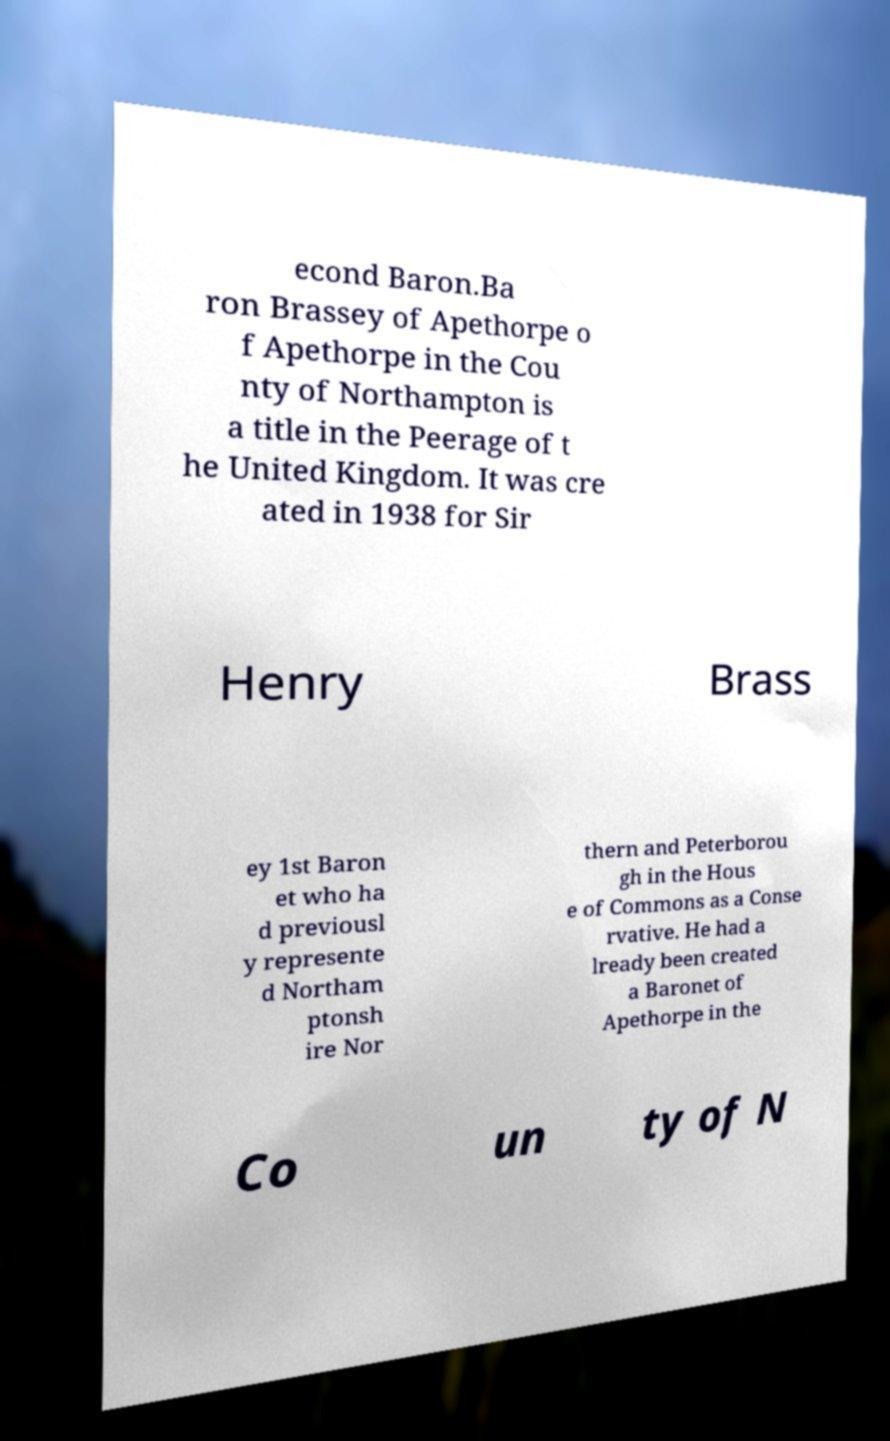Please read and relay the text visible in this image. What does it say? econd Baron.Ba ron Brassey of Apethorpe o f Apethorpe in the Cou nty of Northampton is a title in the Peerage of t he United Kingdom. It was cre ated in 1938 for Sir Henry Brass ey 1st Baron et who ha d previousl y represente d Northam ptonsh ire Nor thern and Peterborou gh in the Hous e of Commons as a Conse rvative. He had a lready been created a Baronet of Apethorpe in the Co un ty of N 